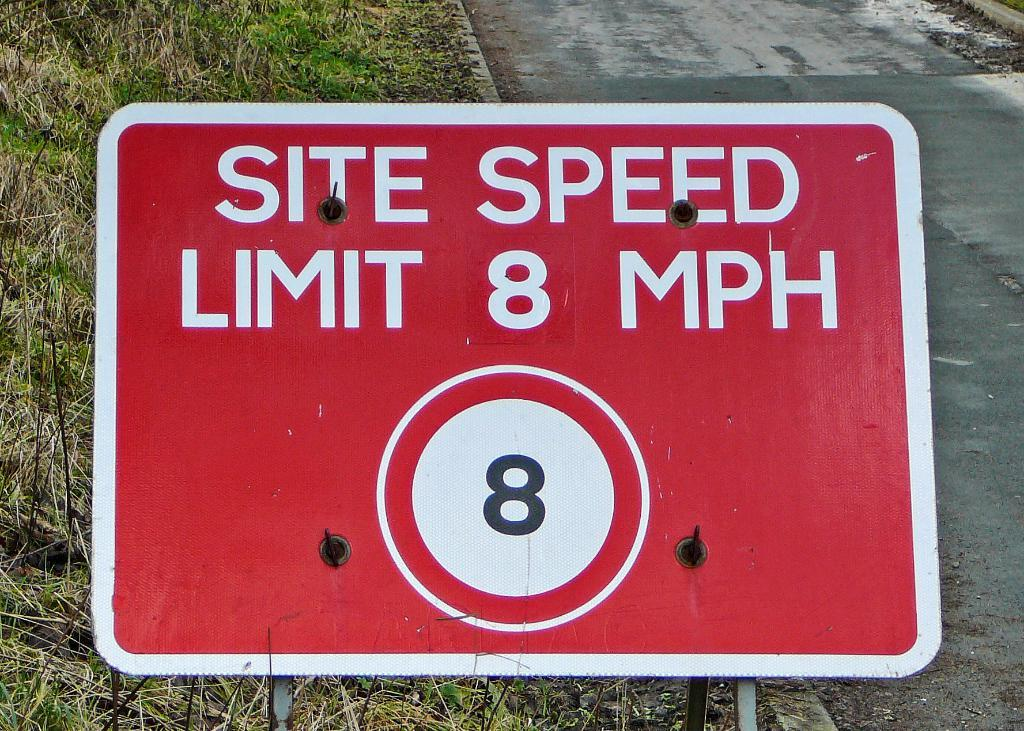<image>
Share a concise interpretation of the image provided. Large red sign which says "Site Speed Limit 8 MPH". 